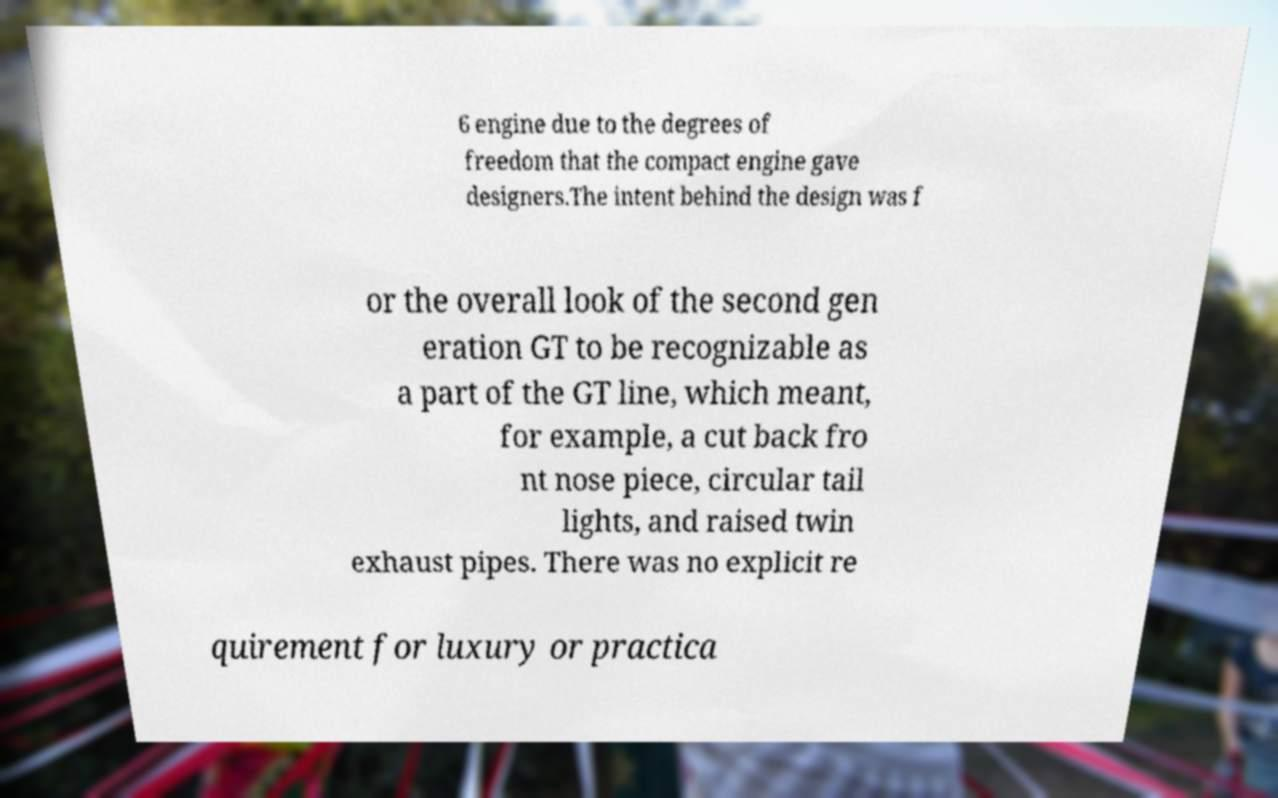What messages or text are displayed in this image? I need them in a readable, typed format. 6 engine due to the degrees of freedom that the compact engine gave designers.The intent behind the design was f or the overall look of the second gen eration GT to be recognizable as a part of the GT line, which meant, for example, a cut back fro nt nose piece, circular tail lights, and raised twin exhaust pipes. There was no explicit re quirement for luxury or practica 